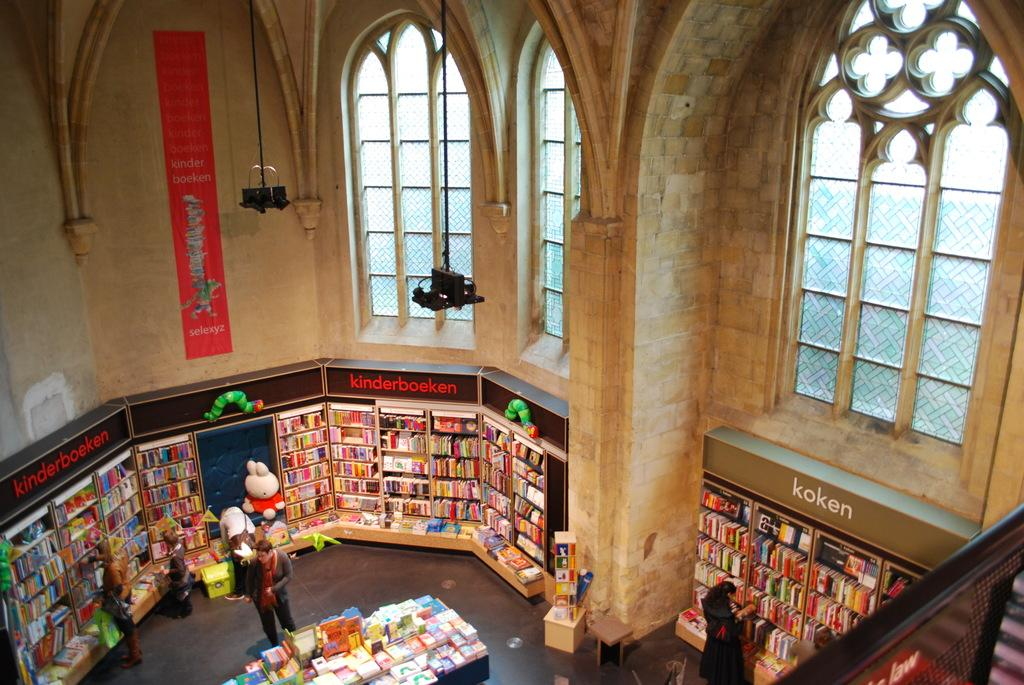<image>
Give a short and clear explanation of the subsequent image. A library with high ceilings has a long red poster with the words kinder boeken included on it. 